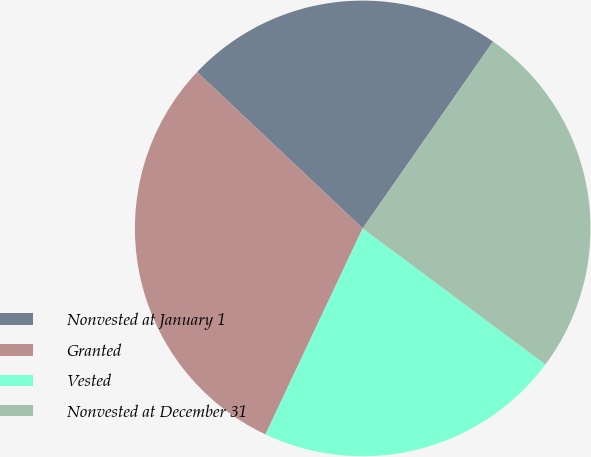Convert chart. <chart><loc_0><loc_0><loc_500><loc_500><pie_chart><fcel>Nonvested at January 1<fcel>Granted<fcel>Vested<fcel>Nonvested at December 31<nl><fcel>22.65%<fcel>30.02%<fcel>21.83%<fcel>25.49%<nl></chart> 